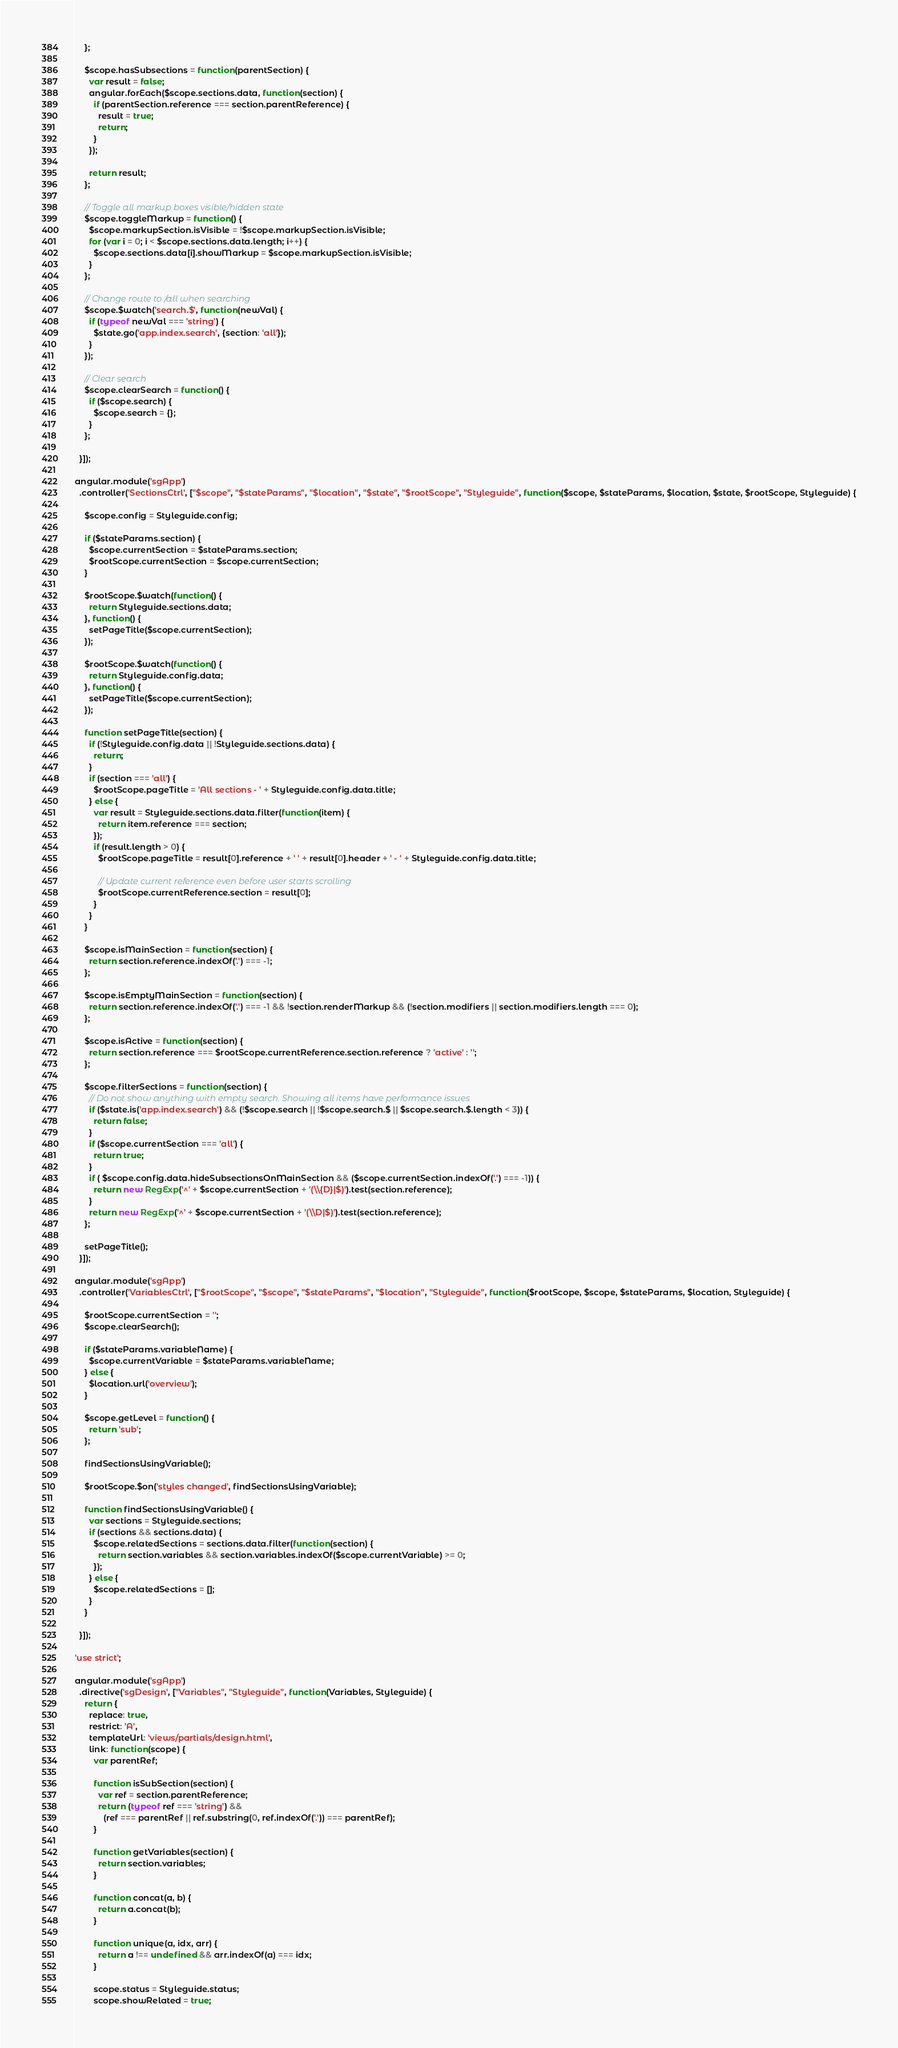Convert code to text. <code><loc_0><loc_0><loc_500><loc_500><_JavaScript_>    };

    $scope.hasSubsections = function(parentSection) {
      var result = false;
      angular.forEach($scope.sections.data, function(section) {
        if (parentSection.reference === section.parentReference) {
          result = true;
          return;
        }
      });

      return result;
    };

    // Toggle all markup boxes visible/hidden state
    $scope.toggleMarkup = function() {
      $scope.markupSection.isVisible = !$scope.markupSection.isVisible;
      for (var i = 0; i < $scope.sections.data.length; i++) {
        $scope.sections.data[i].showMarkup = $scope.markupSection.isVisible;
      }
    };

    // Change route to /all when searching
    $scope.$watch('search.$', function(newVal) {
      if (typeof newVal === 'string') {
        $state.go('app.index.search', {section: 'all'});
      }
    });

    // Clear search
    $scope.clearSearch = function() {
      if ($scope.search) {
        $scope.search = {};
      }
    };

  }]);

angular.module('sgApp')
  .controller('SectionsCtrl', ["$scope", "$stateParams", "$location", "$state", "$rootScope", "Styleguide", function($scope, $stateParams, $location, $state, $rootScope, Styleguide) {

    $scope.config = Styleguide.config;

    if ($stateParams.section) {
      $scope.currentSection = $stateParams.section;
      $rootScope.currentSection = $scope.currentSection;
    }

    $rootScope.$watch(function() {
      return Styleguide.sections.data;
    }, function() {
      setPageTitle($scope.currentSection);
    });

    $rootScope.$watch(function() {
      return Styleguide.config.data;
    }, function() {
      setPageTitle($scope.currentSection);
    });

    function setPageTitle(section) {
      if (!Styleguide.config.data || !Styleguide.sections.data) {
        return;
      }
      if (section === 'all') {
        $rootScope.pageTitle = 'All sections - ' + Styleguide.config.data.title;
      } else {
        var result = Styleguide.sections.data.filter(function(item) {
          return item.reference === section;
        });
        if (result.length > 0) {
          $rootScope.pageTitle = result[0].reference + ' ' + result[0].header + ' - ' + Styleguide.config.data.title;

          // Update current reference even before user starts scrolling
          $rootScope.currentReference.section = result[0];
        }
      }
    }

    $scope.isMainSection = function(section) {
      return section.reference.indexOf('.') === -1;
    };

    $scope.isEmptyMainSection = function(section) {
      return section.reference.indexOf('.') === -1 && !section.renderMarkup && (!section.modifiers || section.modifiers.length === 0);
    };

    $scope.isActive = function(section) {
      return section.reference === $rootScope.currentReference.section.reference ? 'active' : '';
    };

    $scope.filterSections = function(section) {
      // Do not show anything with empty search. Showing all items have performance issues
      if ($state.is('app.index.search') && (!$scope.search || !$scope.search.$ || $scope.search.$.length < 3)) {
        return false;
      }
      if ($scope.currentSection === 'all') {
        return true;
      }
      if ( $scope.config.data.hideSubsectionsOnMainSection && ($scope.currentSection.indexOf('.') === -1)) {
        return new RegExp('^' + $scope.currentSection + '(\\{D}|$)').test(section.reference);
      }
      return new RegExp('^' + $scope.currentSection + '(\\D|$)').test(section.reference);
    };

    setPageTitle();
  }]);

angular.module('sgApp')
  .controller('VariablesCtrl', ["$rootScope", "$scope", "$stateParams", "$location", "Styleguide", function($rootScope, $scope, $stateParams, $location, Styleguide) {

    $rootScope.currentSection = '';
    $scope.clearSearch();

    if ($stateParams.variableName) {
      $scope.currentVariable = $stateParams.variableName;
    } else {
      $location.url('overview');
    }

    $scope.getLevel = function() {
      return 'sub';
    };

    findSectionsUsingVariable();

    $rootScope.$on('styles changed', findSectionsUsingVariable);

    function findSectionsUsingVariable() {
      var sections = Styleguide.sections;
      if (sections && sections.data) {
        $scope.relatedSections = sections.data.filter(function(section) {
          return section.variables && section.variables.indexOf($scope.currentVariable) >= 0;
        });
      } else {
        $scope.relatedSections = [];
      }
    }

  }]);

'use strict';

angular.module('sgApp')
  .directive('sgDesign', ["Variables", "Styleguide", function(Variables, Styleguide) {
    return {
      replace: true,
      restrict: 'A',
      templateUrl: 'views/partials/design.html',
      link: function(scope) {
        var parentRef;

        function isSubSection(section) {
          var ref = section.parentReference;
          return (typeof ref === 'string') &&
            (ref === parentRef || ref.substring(0, ref.indexOf('.')) === parentRef);
        }

        function getVariables(section) {
          return section.variables;
        }

        function concat(a, b) {
          return a.concat(b);
        }

        function unique(a, idx, arr) {
          return a !== undefined && arr.indexOf(a) === idx;
        }

        scope.status = Styleguide.status;
        scope.showRelated = true;
</code> 